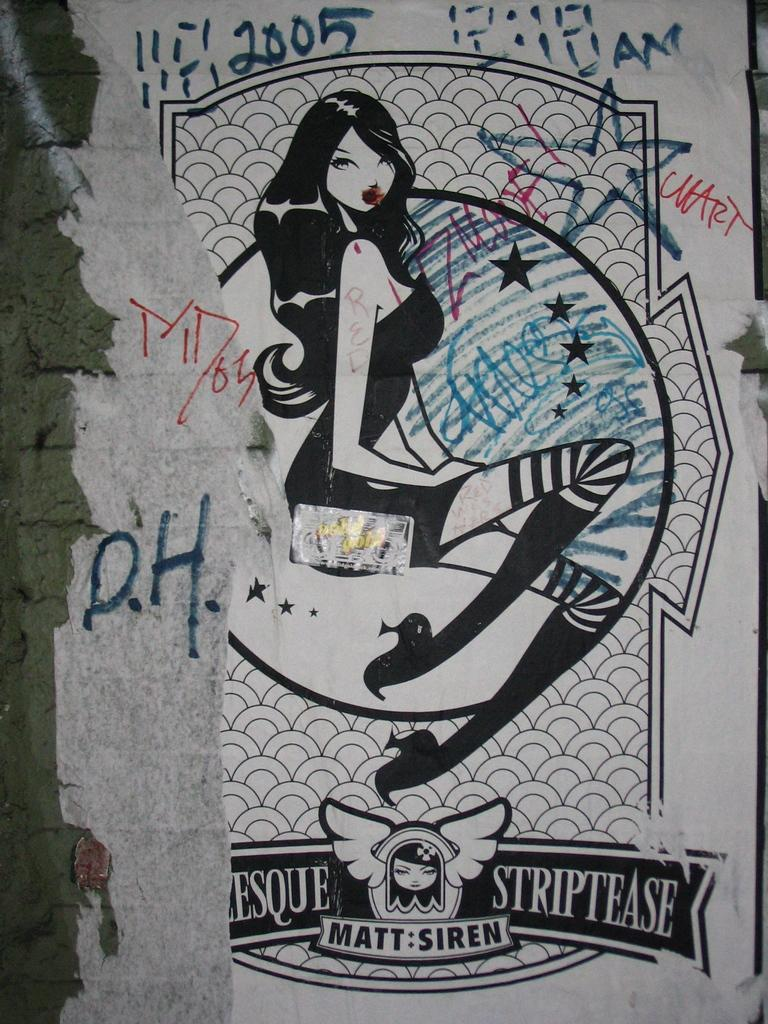What is depicted on the paper in the image? There is a sketch of a woman on a paper in the image. Are there any words or phrases on the paper? Yes, there is writing on the paper. What is the color scheme of the image? The image is black and white. How many dolls are involved in the plot of the image? There are no dolls or plots present in the image; it features a sketch of a woman and writing on a paper. 